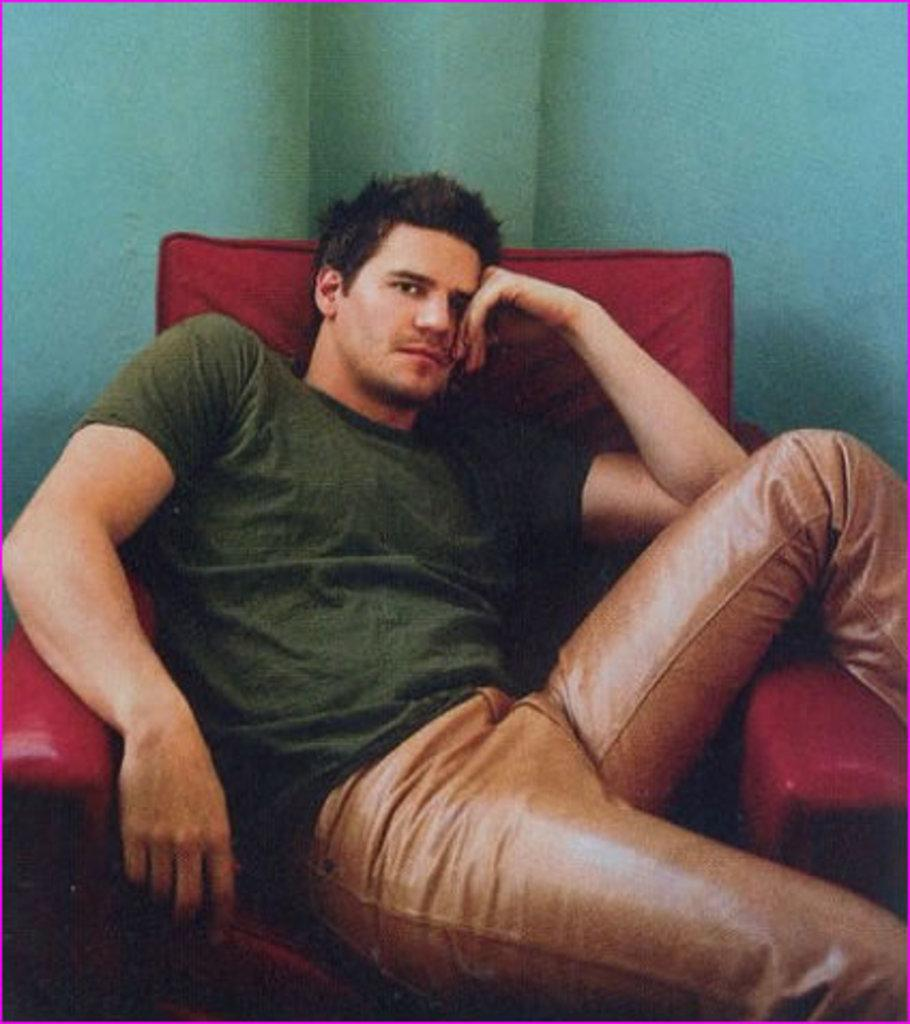Who or what is the main subject in the image? There is a person in the image. What is the person doing in the image? The person is sitting on a chair. What can be seen behind the person in the image? There is a wall in the background of the image. What type of face can be seen on the wall in the image? There is no face visible on the wall in the image. 